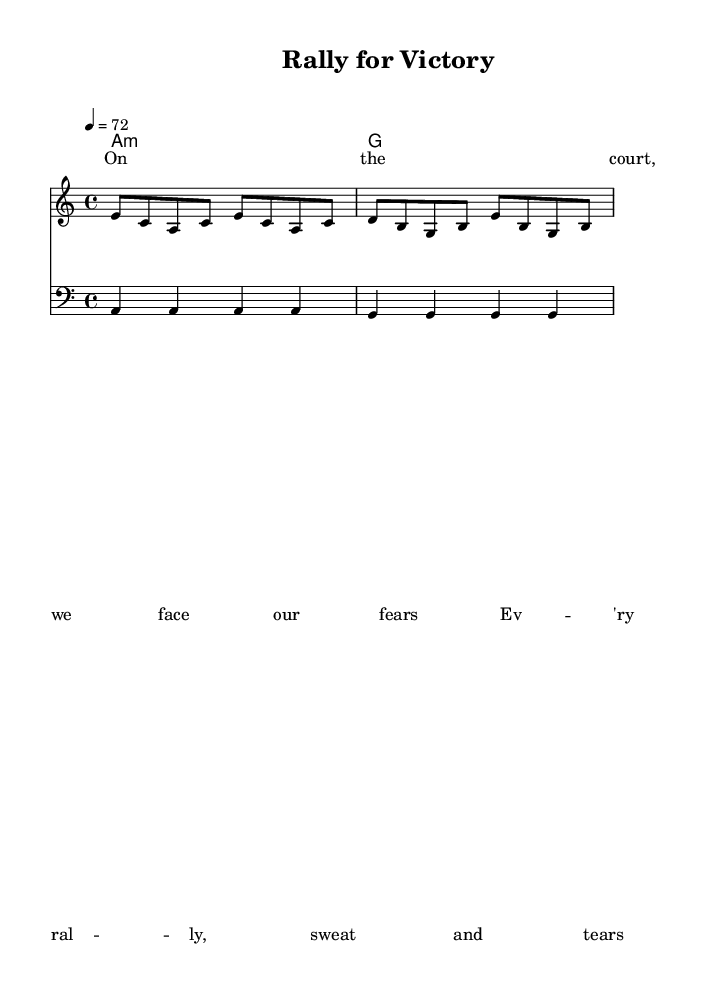What is the key signature of this music? The key signature is A minor, which has no sharps or flats.
Answer: A minor What is the time signature of this music? The time signature is indicated at the beginning of the score as 4/4, meaning there are four beats in each measure.
Answer: 4/4 What is the tempo marking for this piece? The tempo marking in the score indicates a tempo of 72 beats per minute (quarter note).
Answer: 72 What is the total number of measures in the melody section? The melody section has a total of 4 measures, counted from the melody's notation.
Answer: 4 What is the first lyric line in the verse? The first lyric line reads "On the court, we face our fears," as noted in the lyric section of the score.
Answer: "On the court, we face our fears." What is the chord used in the harmonies section? The first chord in the harmonies is an A minor, as indicated by the "a1:m" notational format.
Answer: A minor Which reggae theme is reflected in the lyrics of this song? The lyrics express themes of perseverance and overcoming challenges, crucial elements of the reggae genre's storytelling.
Answer: Perseverance 